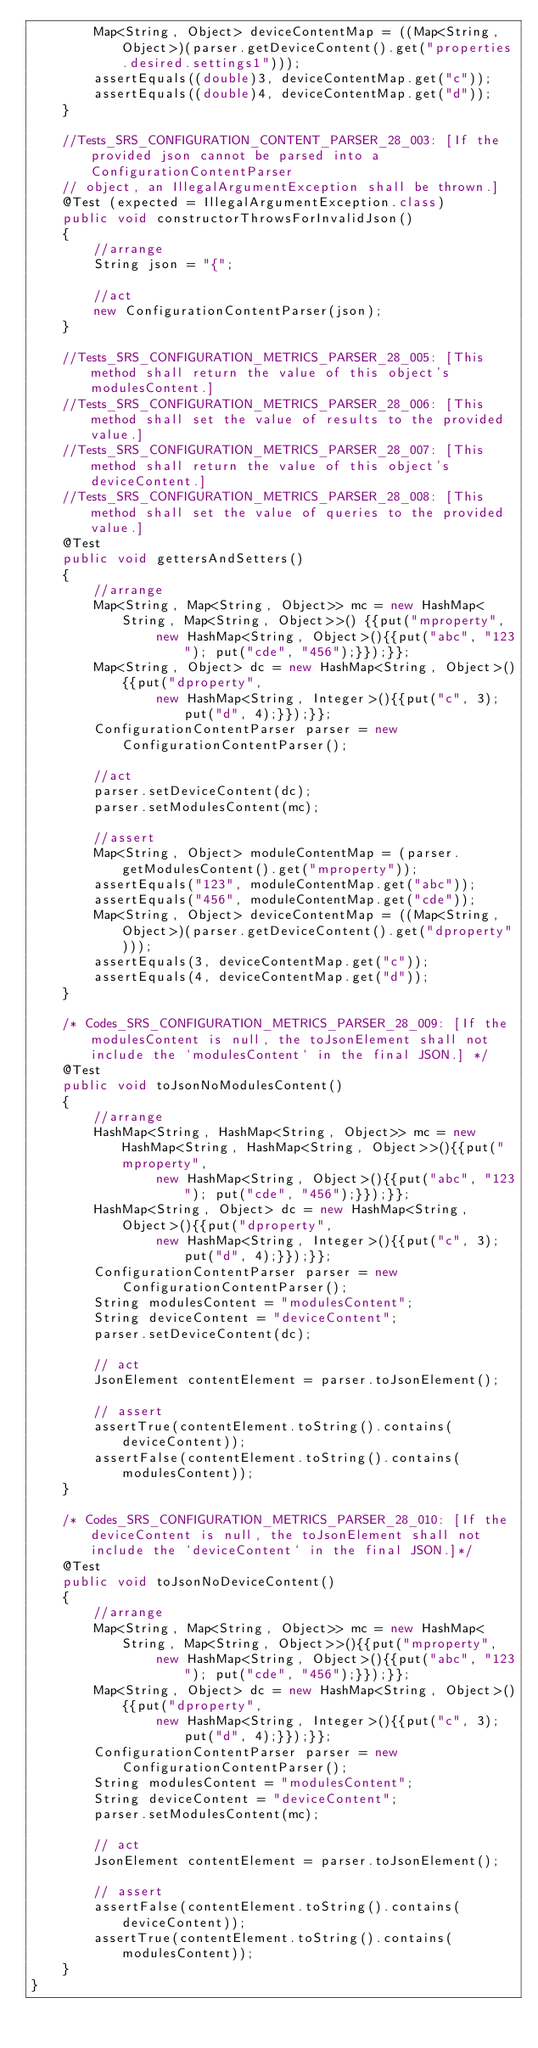<code> <loc_0><loc_0><loc_500><loc_500><_Java_>        Map<String, Object> deviceContentMap = ((Map<String,Object>)(parser.getDeviceContent().get("properties.desired.settings1")));
        assertEquals((double)3, deviceContentMap.get("c"));
        assertEquals((double)4, deviceContentMap.get("d"));
    }

    //Tests_SRS_CONFIGURATION_CONTENT_PARSER_28_003: [If the provided json cannot be parsed into a ConfigurationContentParser
    // object, an IllegalArgumentException shall be thrown.]
    @Test (expected = IllegalArgumentException.class)
    public void constructorThrowsForInvalidJson()
    {
        //arrange
        String json = "{";

        //act
        new ConfigurationContentParser(json);
    }

    //Tests_SRS_CONFIGURATION_METRICS_PARSER_28_005: [This method shall return the value of this object's modulesContent.]
    //Tests_SRS_CONFIGURATION_METRICS_PARSER_28_006: [This method shall set the value of results to the provided value.]
    //Tests_SRS_CONFIGURATION_METRICS_PARSER_28_007: [This method shall return the value of this object's deviceContent.]
    //Tests_SRS_CONFIGURATION_METRICS_PARSER_28_008: [This method shall set the value of queries to the provided value.]
    @Test
    public void gettersAndSetters()
    {
        //arrange
        Map<String, Map<String, Object>> mc = new HashMap<String, Map<String, Object>>() {{put("mproperty",
                new HashMap<String, Object>(){{put("abc", "123"); put("cde", "456");}});}};
        Map<String, Object> dc = new HashMap<String, Object>(){{put("dproperty",
                new HashMap<String, Integer>(){{put("c", 3);put("d", 4);}});}};
        ConfigurationContentParser parser = new ConfigurationContentParser();

        //act
        parser.setDeviceContent(dc);
        parser.setModulesContent(mc);

        //assert
        Map<String, Object> moduleContentMap = (parser.getModulesContent().get("mproperty"));
        assertEquals("123", moduleContentMap.get("abc"));
        assertEquals("456", moduleContentMap.get("cde"));
        Map<String, Object> deviceContentMap = ((Map<String,Object>)(parser.getDeviceContent().get("dproperty")));
        assertEquals(3, deviceContentMap.get("c"));
        assertEquals(4, deviceContentMap.get("d"));
    }

    /* Codes_SRS_CONFIGURATION_METRICS_PARSER_28_009: [If the modulesContent is null, the toJsonElement shall not include the `modulesContent` in the final JSON.] */
    @Test
    public void toJsonNoModulesContent()
    {
        //arrange
        HashMap<String, HashMap<String, Object>> mc = new HashMap<String, HashMap<String, Object>>(){{put("mproperty",
                new HashMap<String, Object>(){{put("abc", "123"); put("cde", "456");}});}};
        HashMap<String, Object> dc = new HashMap<String, Object>(){{put("dproperty",
                new HashMap<String, Integer>(){{put("c", 3);put("d", 4);}});}};
        ConfigurationContentParser parser = new ConfigurationContentParser();
        String modulesContent = "modulesContent";
        String deviceContent = "deviceContent";
        parser.setDeviceContent(dc);

        // act
        JsonElement contentElement = parser.toJsonElement();

        // assert
        assertTrue(contentElement.toString().contains(deviceContent));
        assertFalse(contentElement.toString().contains(modulesContent));
    }

    /* Codes_SRS_CONFIGURATION_METRICS_PARSER_28_010: [If the deviceContent is null, the toJsonElement shall not include the `deviceContent` in the final JSON.]*/
    @Test
    public void toJsonNoDeviceContent()
    {
        //arrange
        Map<String, Map<String, Object>> mc = new HashMap<String, Map<String, Object>>(){{put("mproperty",
                new HashMap<String, Object>(){{put("abc", "123"); put("cde", "456");}});}};
        Map<String, Object> dc = new HashMap<String, Object>(){{put("dproperty",
                new HashMap<String, Integer>(){{put("c", 3);put("d", 4);}});}};
        ConfigurationContentParser parser = new ConfigurationContentParser();
        String modulesContent = "modulesContent";
        String deviceContent = "deviceContent";
        parser.setModulesContent(mc);

        // act
        JsonElement contentElement = parser.toJsonElement();

        // assert
        assertFalse(contentElement.toString().contains(deviceContent));
        assertTrue(contentElement.toString().contains(modulesContent));
    }
}
</code> 